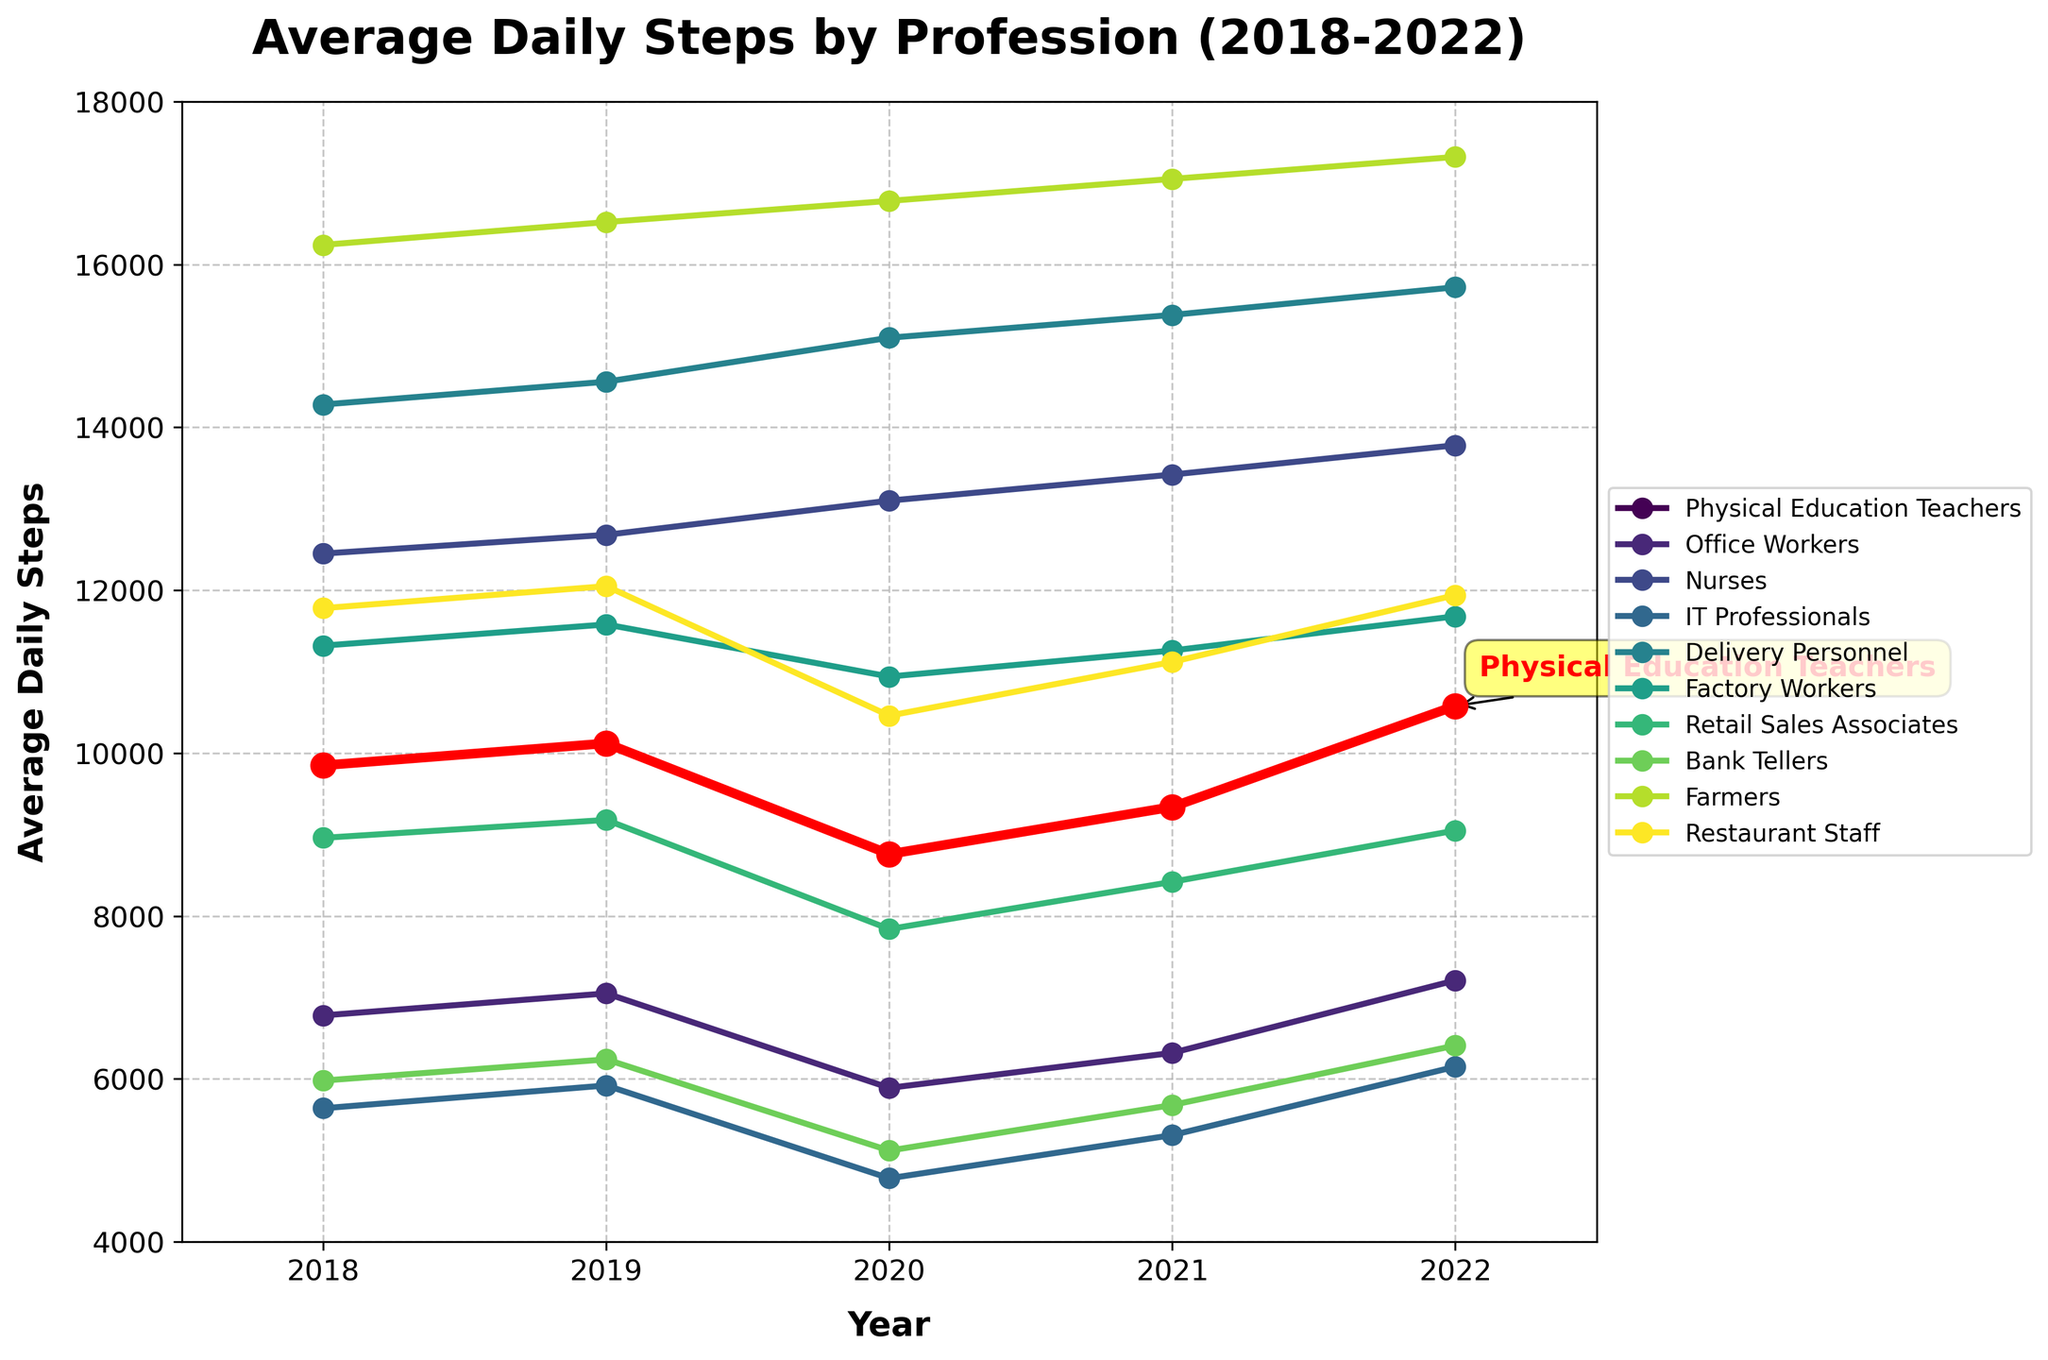What profession has the highest average daily steps in 2022? Look at the data points for each profession in the year 2022. Farmers have the highest number at 17320 steps.
Answer: Farmers What trend do Physical Education Teachers show between 2018 and 2022? Looking at the plot, Physical Education Teachers’ steps decreased from 2018 to 2020 but then increased in 2021 and further in 2022.
Answer: Decrease then increase Compare the average daily steps of Office Workers and Factory Workers in 2020. Office Workers have 5890 steps while Factory Workers have 10940 steps in 2020. Comparing these values, Factory Workers take more steps.
Answer: Factory Workers take more steps Which profession shows a consistent increase in average daily steps every year from 2018 to 2022? By examining the plot, Delivery Personnel have a steady increase from 14280 in 2018 to 15720 in 2022.
Answer: Delivery Personnel In which year did Physical Education Teachers have the lowest average daily steps? The points for Physical Education Teachers show the lowest value of 8760 in 2020.
Answer: 2020 How much did the average daily steps of Nurses increase from 2018 to 2022? The value for Nurses in 2018 is 12450 and in 2022 it is 13780. The increase is 13780 - 12450 = 1330 steps.
Answer: 1330 steps Are Physical Education Teachers’ average daily steps higher or lower than Retail Sales Associates in 2022? The plot shows Physical Education Teachers at 10580 steps and Retail Sales Associates at 9050 steps in 2022. Thus, Physical Education Teachers are higher.
Answer: Higher What is the difference in average daily steps between IT Professionals and Bank Tellers in 2022? In 2022, IT Professionals have 6150 steps and Bank Tellers have 6410 steps. The difference is 6410 - 6150 = 260 steps.
Answer: 260 steps Which profession had the highest average daily steps in 2019? The data points show that Farmers had the highest steps in 2019 with 16520.
Answer: Farmers What visual attributes highlight Physical Education Teachers in the plot? Physical Education Teachers are highlighted with a thick red line and larger red markers. Additionally, a text annotation in yellow with an arrow points to their data.
Answer: Thick red line, larger red markers, yellow annotation 